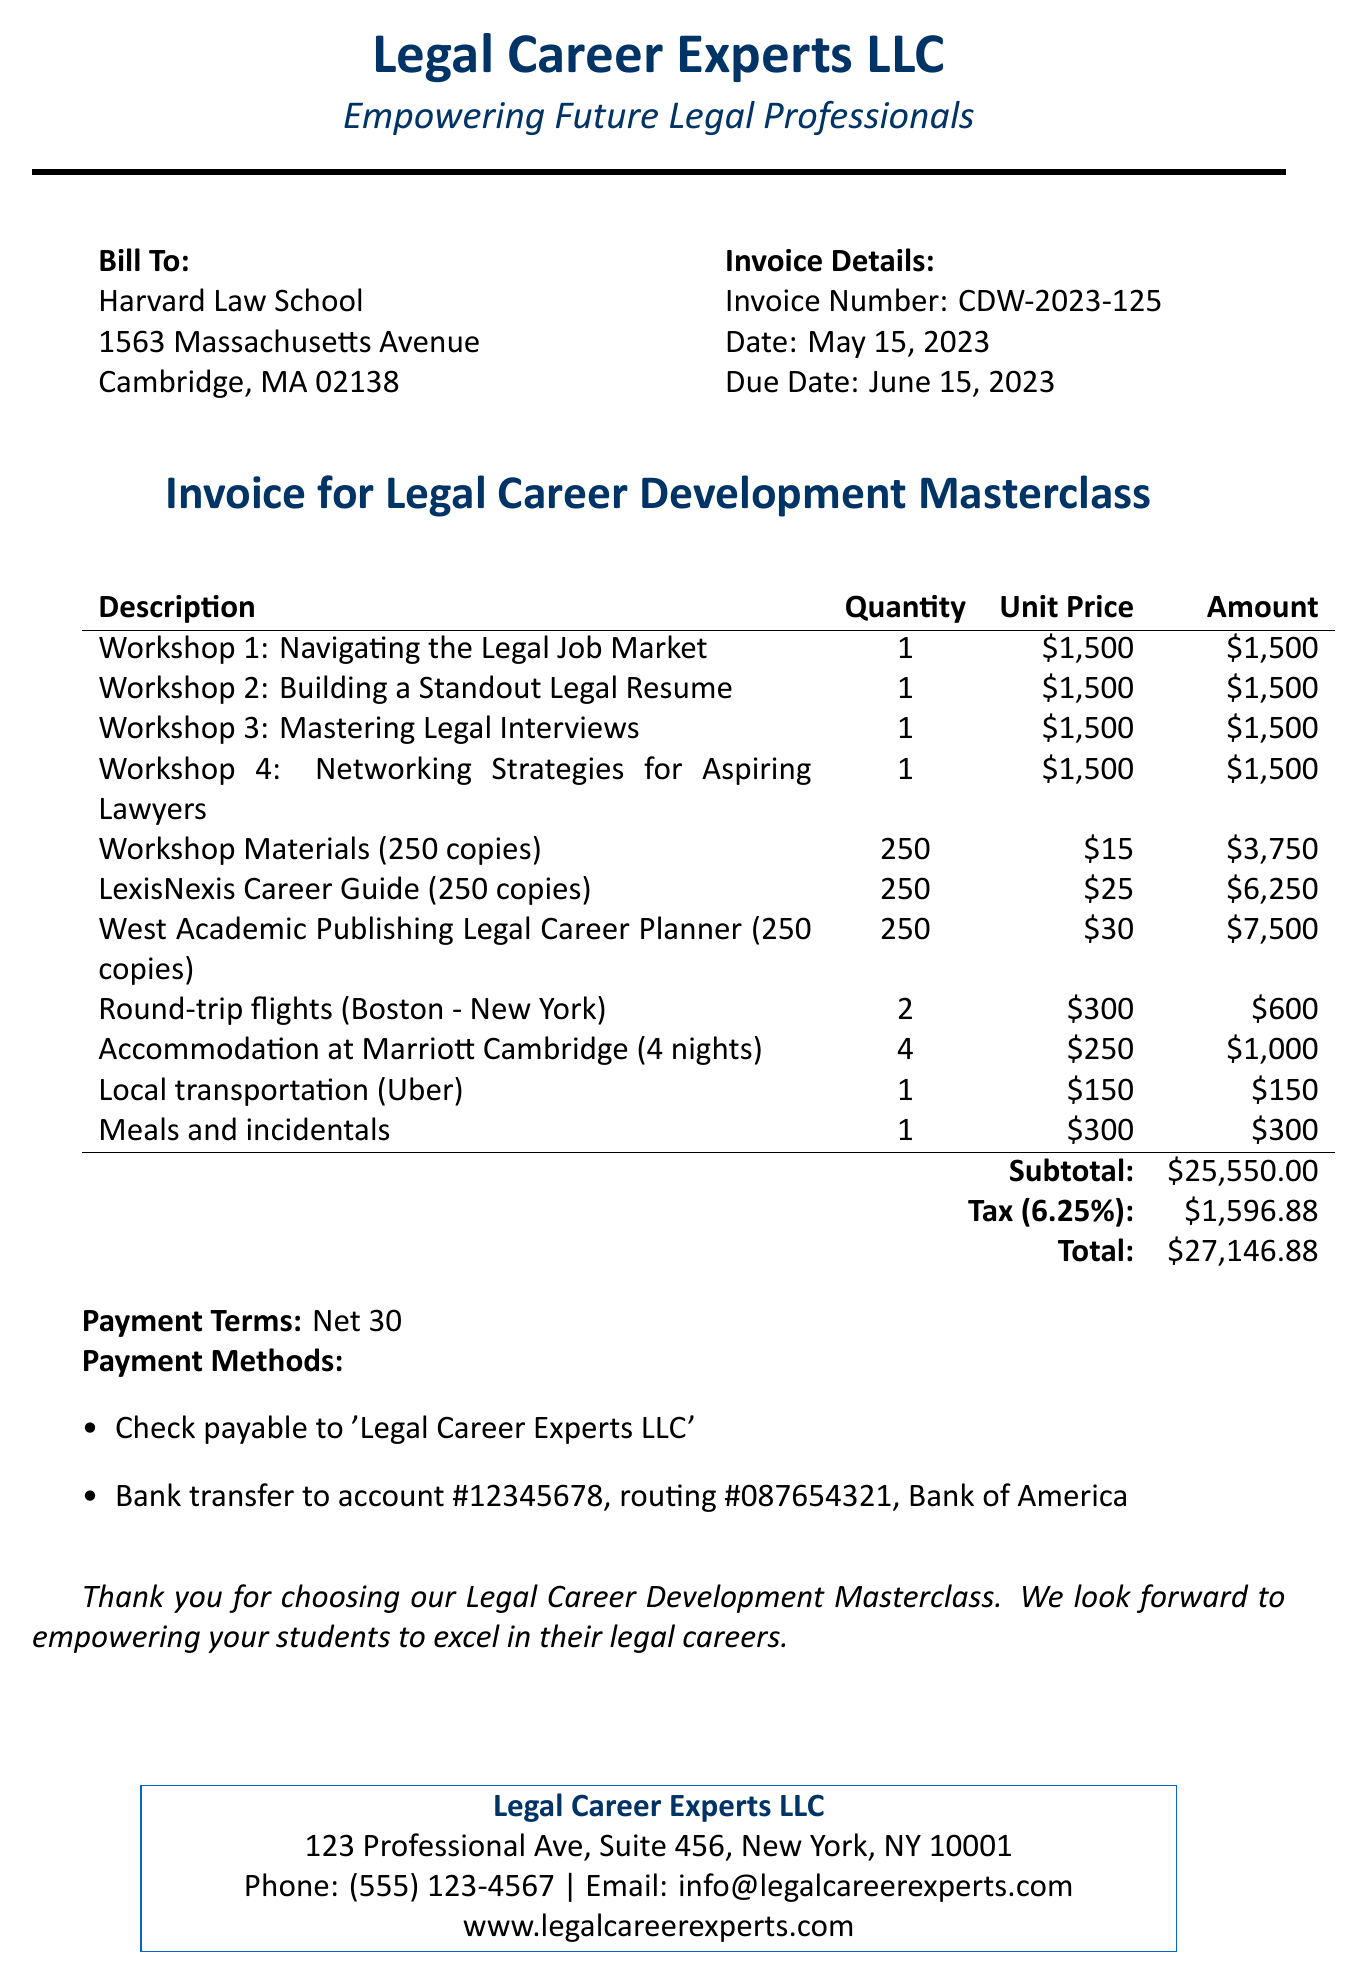What is the invoice number? The invoice number is listed in the invoice details section of the document.
Answer: CDW-2023-125 What is the subtotal amount? The subtotal amount is the total before tax, found at the bottom of the line items table.
Answer: $25,550.00 What are the payment terms? The payment terms are specified clearly in the document after the total amount.
Answer: Net 30 How many workshops are listed in the invoice? The invoice lists four workshops based on the descriptions provided in the line items.
Answer: 4 What is the total amount due? The total amount is the final figure including tax, found at the end of the invoice.
Answer: $27,146.88 How many copies of the West Academic Publishing Legal Career Planner are being ordered? The quantity of copies ordered is shown alongside the description of the item in the line items.
Answer: 250 What is the tax rate applied to the invoice? The tax rate is mentioned in the tax calculation section of the document.
Answer: 6.25% How much is allocated for meals and incidentals? The specific amount for meals and incidentals is detailed in the line items of the invoice.
Answer: $300 What is the due date for the invoice? The due date is outlined in the invoice details section.
Answer: June 15, 2023 